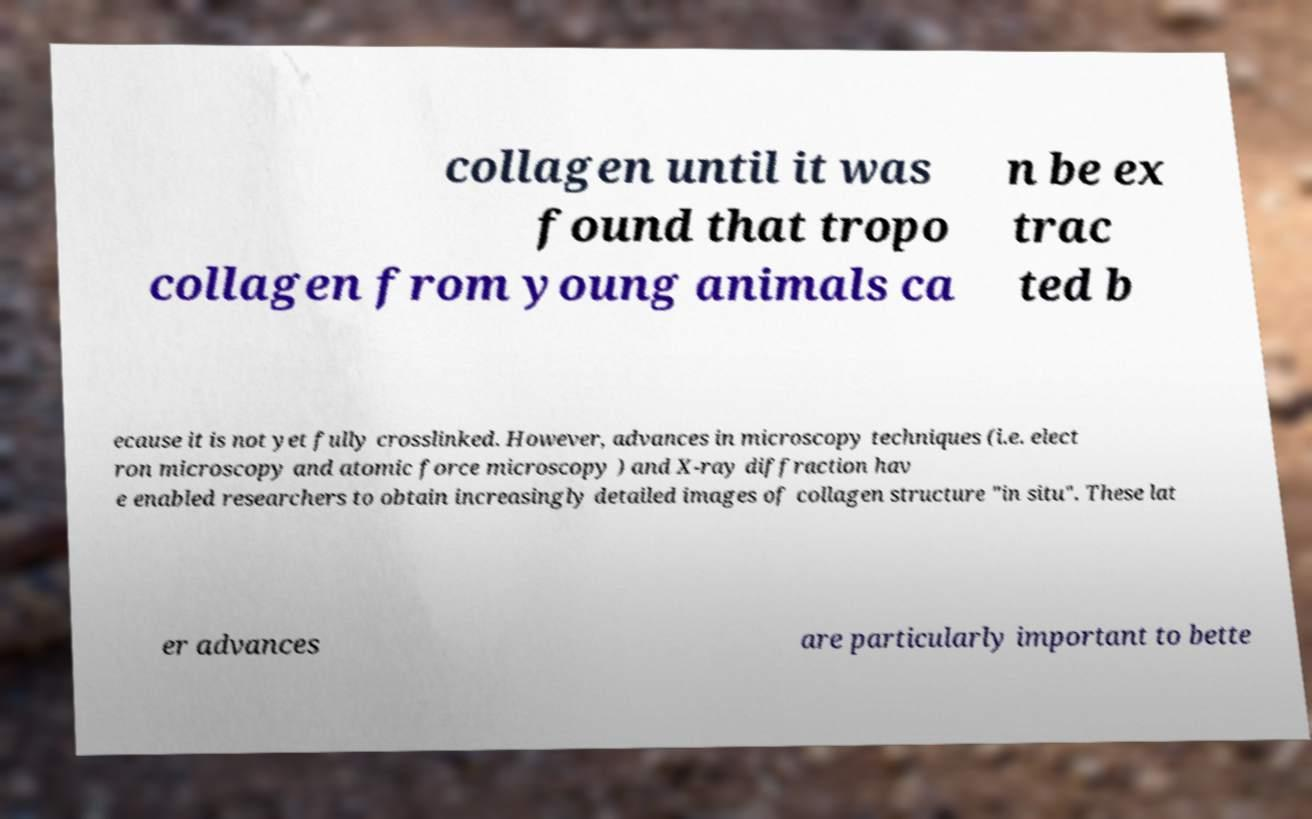Could you assist in decoding the text presented in this image and type it out clearly? collagen until it was found that tropo collagen from young animals ca n be ex trac ted b ecause it is not yet fully crosslinked. However, advances in microscopy techniques (i.e. elect ron microscopy and atomic force microscopy ) and X-ray diffraction hav e enabled researchers to obtain increasingly detailed images of collagen structure "in situ". These lat er advances are particularly important to bette 